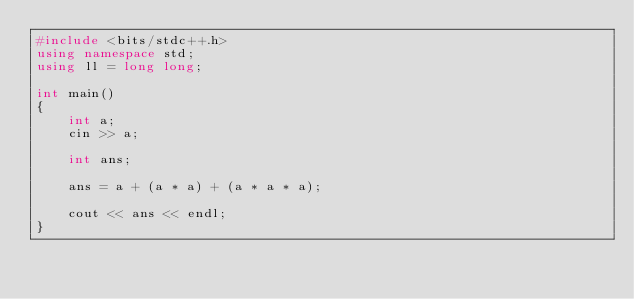<code> <loc_0><loc_0><loc_500><loc_500><_C++_>#include <bits/stdc++.h>
using namespace std;
using ll = long long;

int main()
{
    int a;
    cin >> a;

    int ans;

    ans = a + (a * a) + (a * a * a);

    cout << ans << endl;
}</code> 